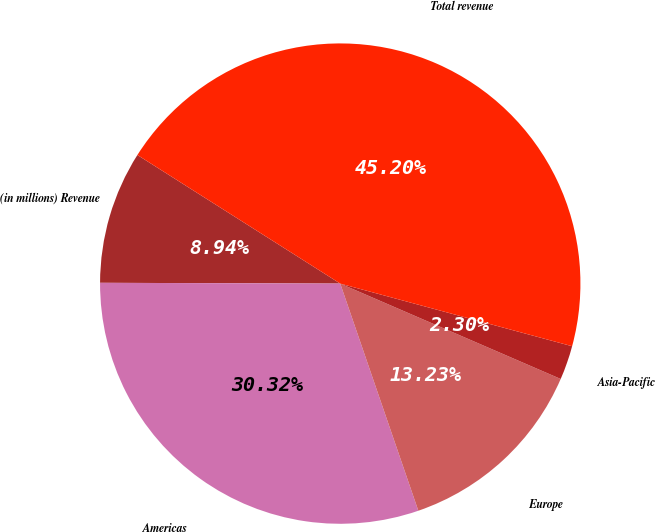<chart> <loc_0><loc_0><loc_500><loc_500><pie_chart><fcel>(in millions) Revenue<fcel>Americas<fcel>Europe<fcel>Asia-Pacific<fcel>Total revenue<nl><fcel>8.94%<fcel>30.32%<fcel>13.23%<fcel>2.3%<fcel>45.2%<nl></chart> 